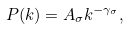<formula> <loc_0><loc_0><loc_500><loc_500>P ( k ) = A _ { \sigma } k ^ { - \gamma _ { \sigma } } ,</formula> 